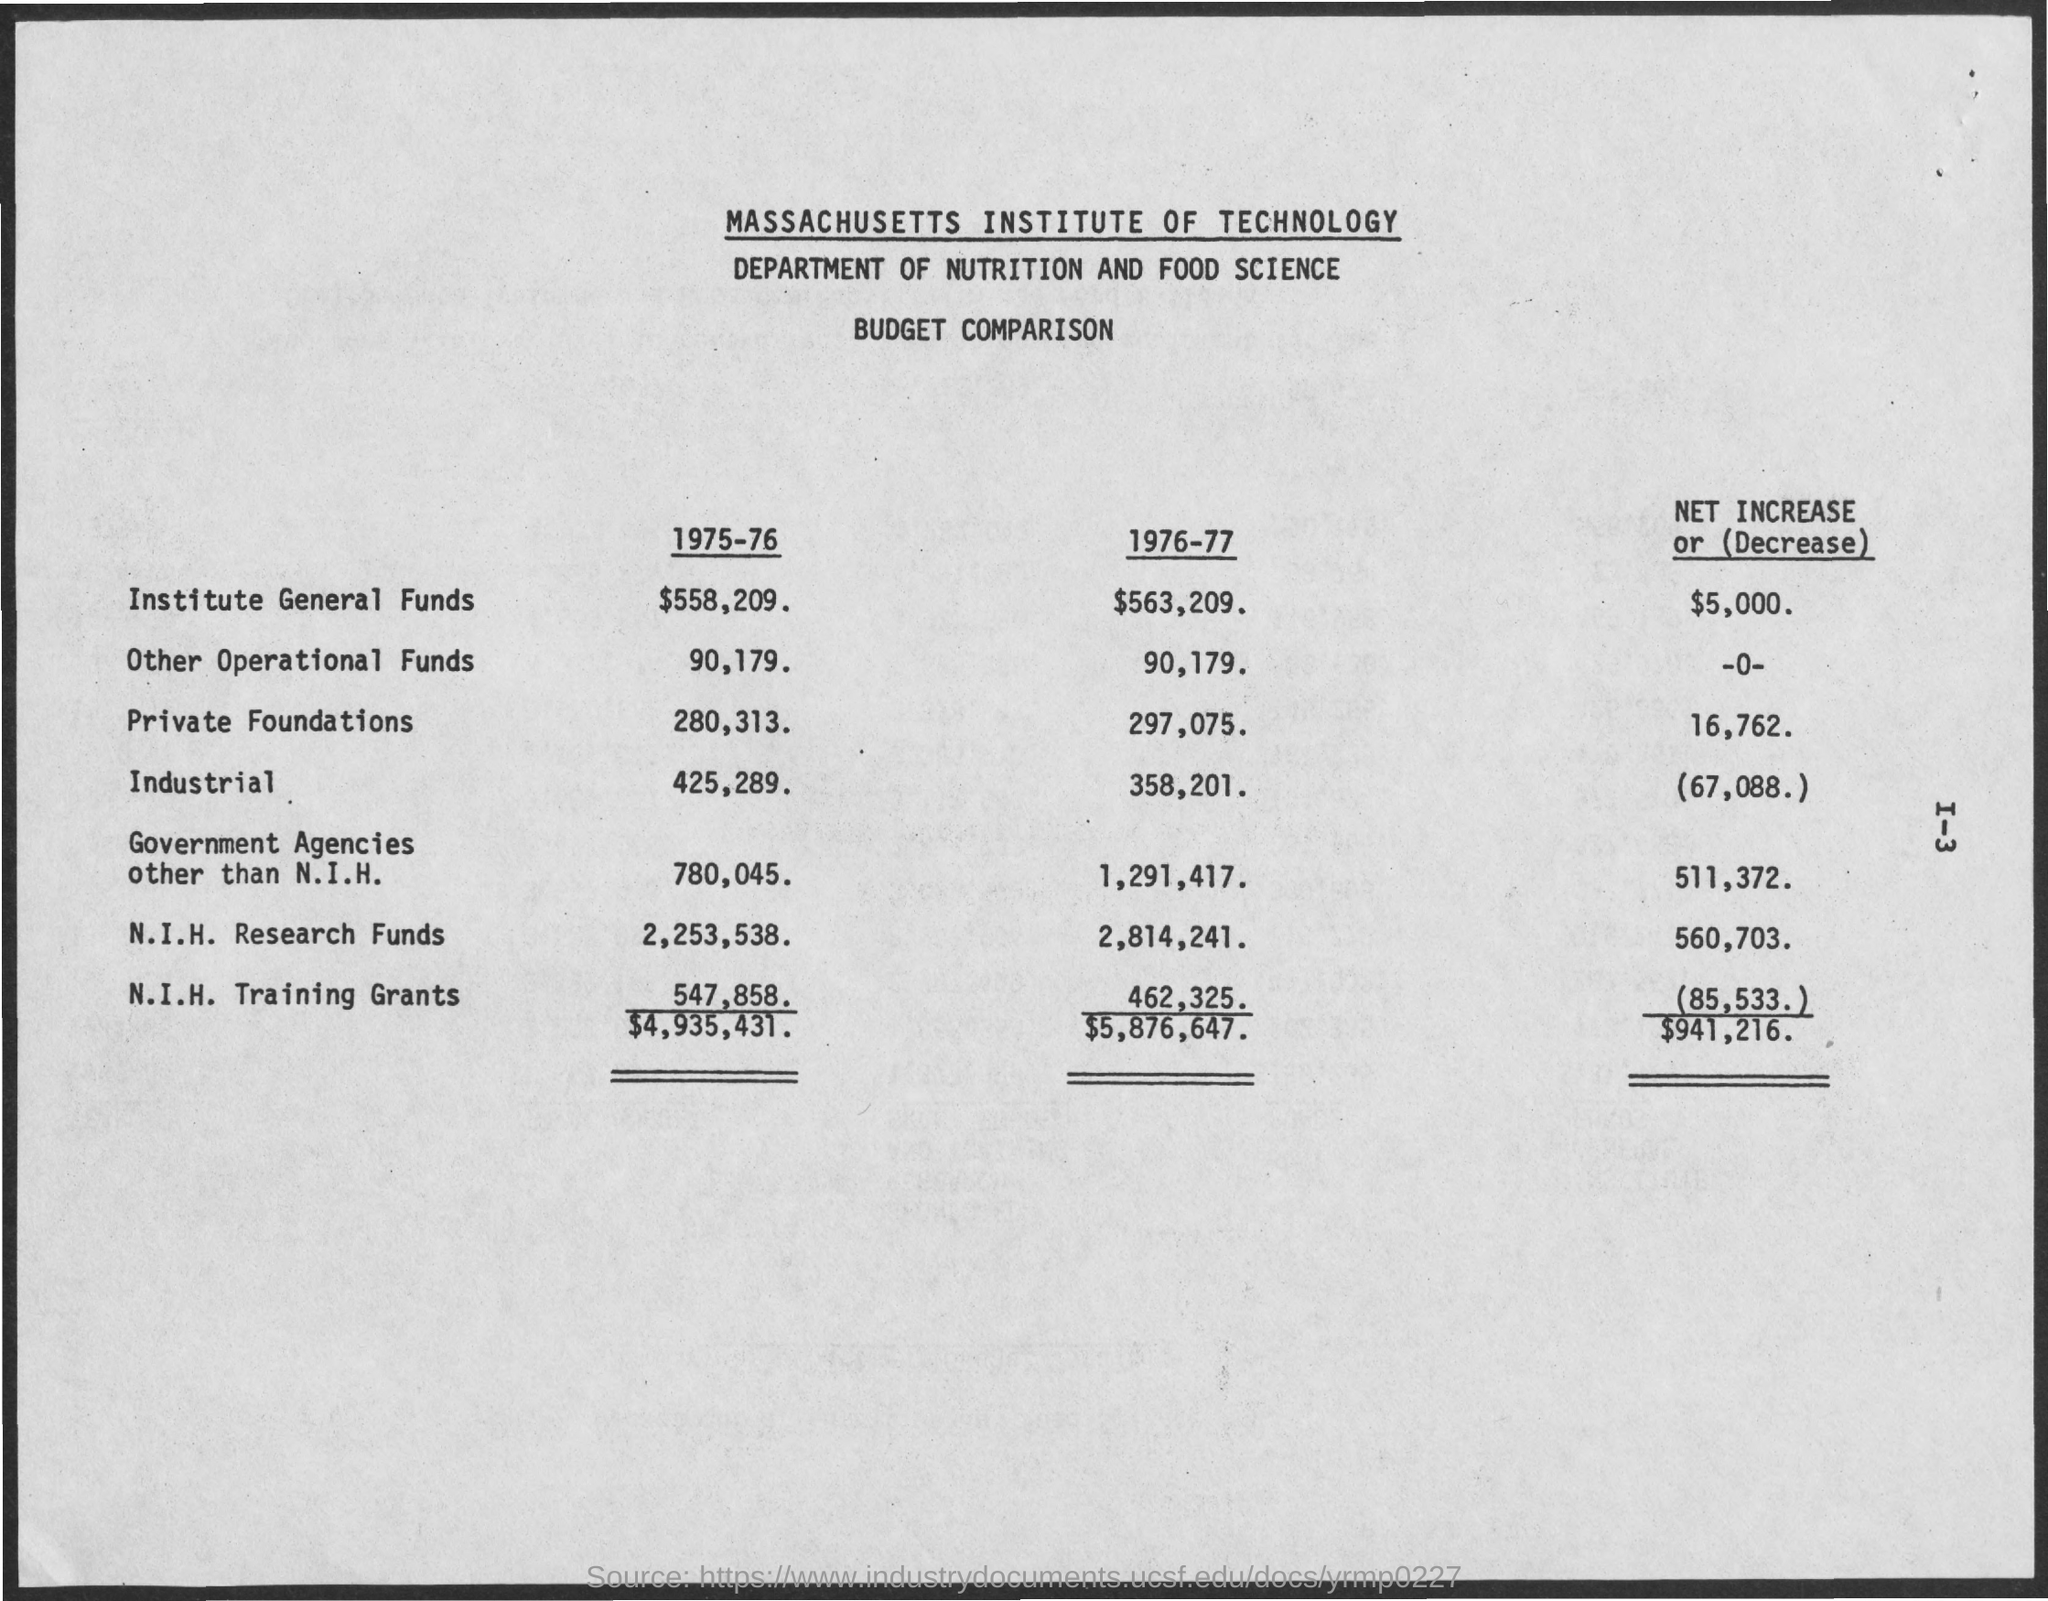Specify some key components in this picture. The private foundations for the year 1975-1976 were 280,313. The Other Operational Funds for the year 1976-77 were approximately $90,179. The Institute had General Funds of $558,209 for the year 1975-76. The National Institutes of Health (NIH) Training Grants for 1976-77 were awarded a total of $462,325. The Other Operational Funds for the year 1975-76 was 90,179. 